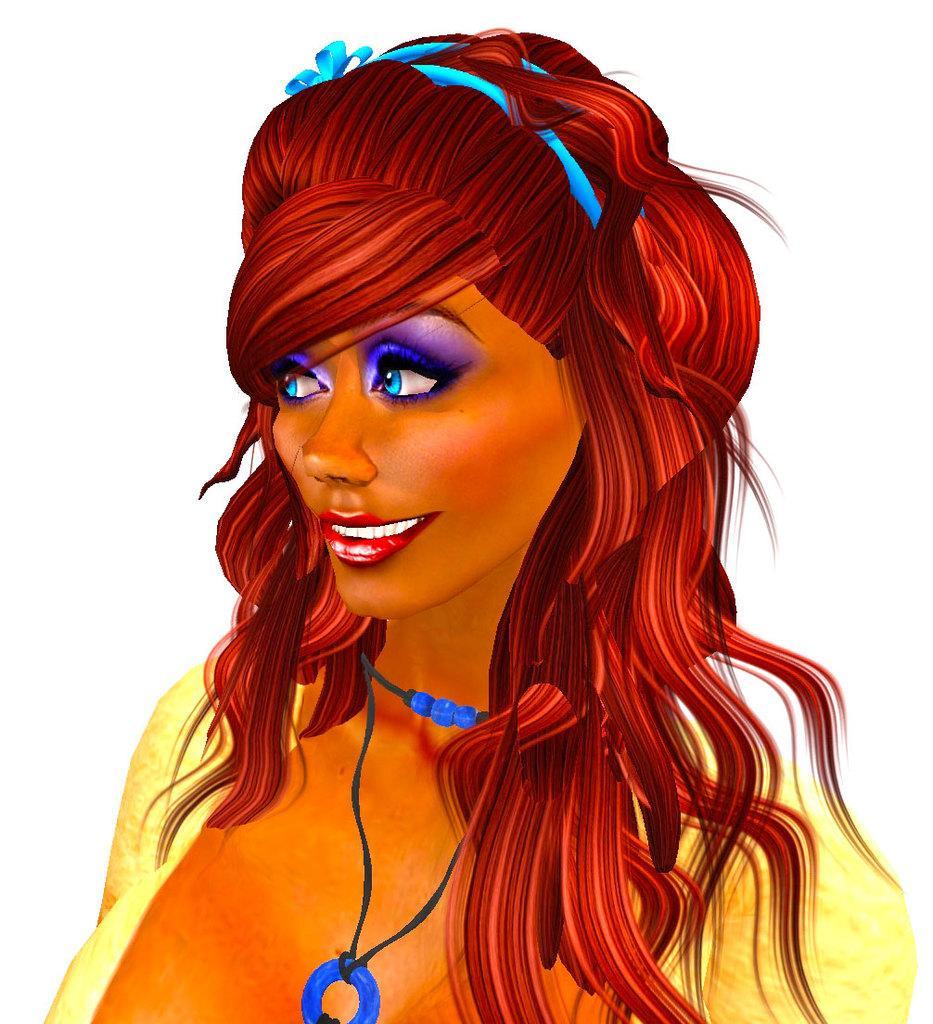Please provide a concise description of this image. In this picture, there is a cartoon which is woman. She is wearing a yellow top and blue necklace. 